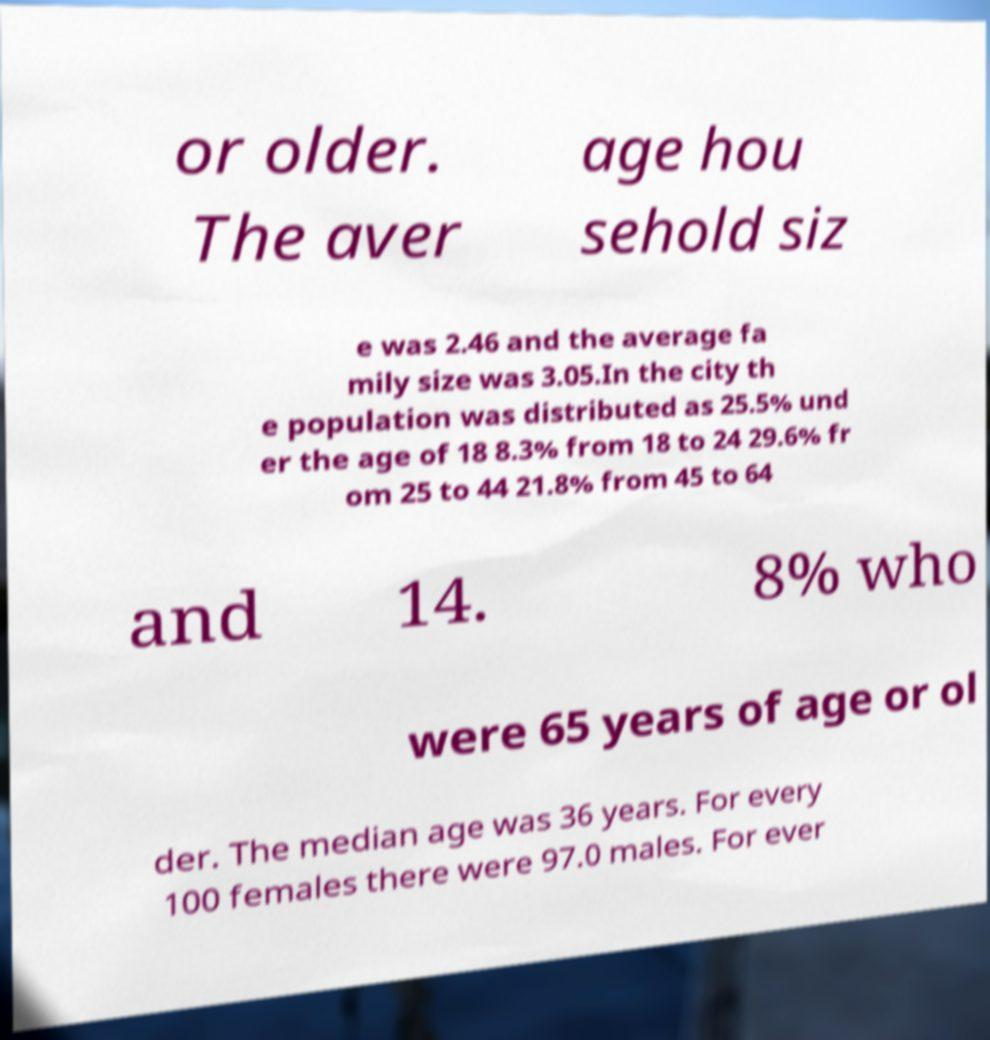Could you extract and type out the text from this image? or older. The aver age hou sehold siz e was 2.46 and the average fa mily size was 3.05.In the city th e population was distributed as 25.5% und er the age of 18 8.3% from 18 to 24 29.6% fr om 25 to 44 21.8% from 45 to 64 and 14. 8% who were 65 years of age or ol der. The median age was 36 years. For every 100 females there were 97.0 males. For ever 